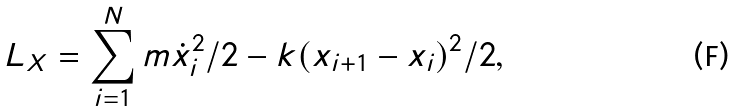Convert formula to latex. <formula><loc_0><loc_0><loc_500><loc_500>L _ { X } = \sum _ { i = 1 } ^ { N } m \dot { x } _ { i } ^ { 2 } / 2 - k ( x _ { i + 1 } - x _ { i } ) ^ { 2 } / 2 ,</formula> 